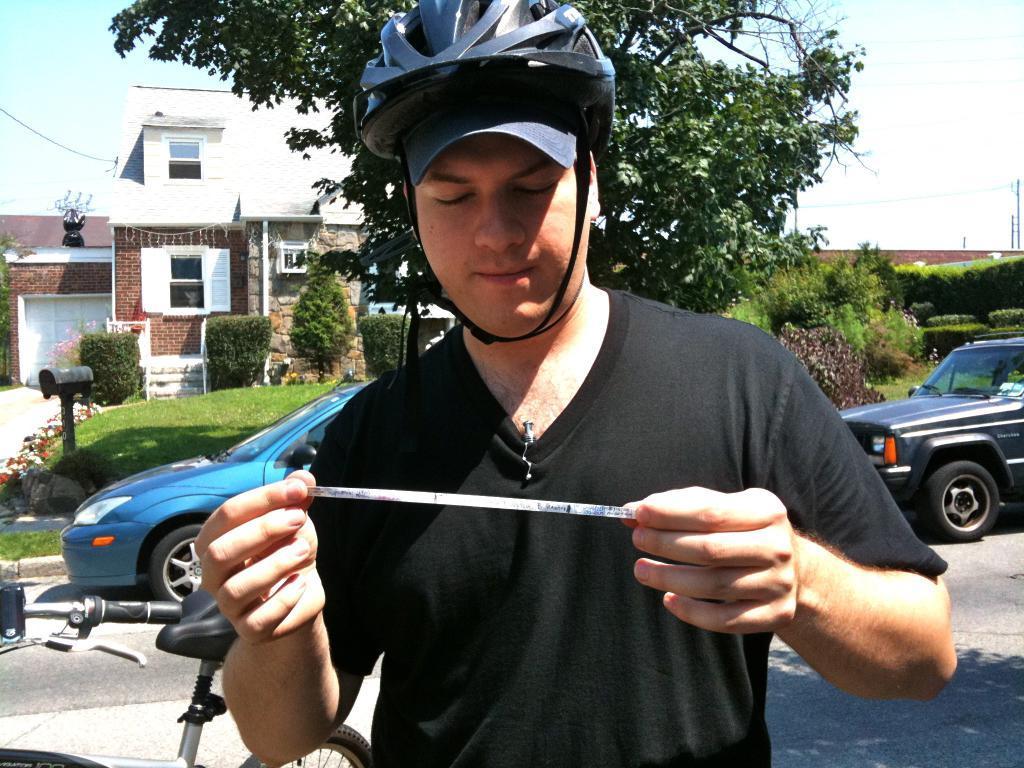What is the person in the image doing? The person is standing in the image and holding a paper. What can be seen on the road in the image? There are vehicles on the road in the image. What type of natural environment is visible in the background of the image? There are trees, grass, and the sky visible in the background of the image. What structures can be seen in the background of the image? There is a building, a box, and a pole visible in the background of the image. What type of knee is visible in the image? There is no knee visible in the image; the person is standing and holding a paper. How many steps are present in the image? There is no mention of steps in the image; it features a person standing, vehicles on the road, and various elements in the background. 